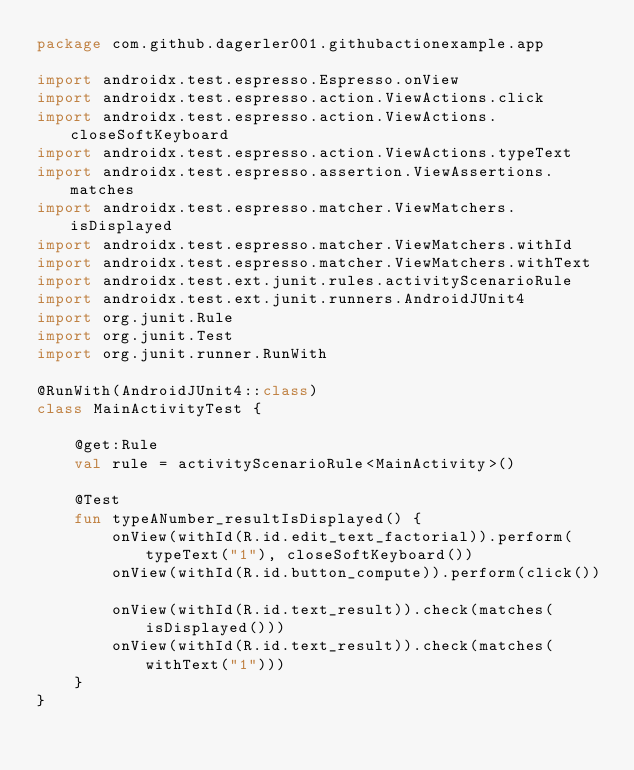Convert code to text. <code><loc_0><loc_0><loc_500><loc_500><_Kotlin_>package com.github.dagerler001.githubactionexample.app

import androidx.test.espresso.Espresso.onView
import androidx.test.espresso.action.ViewActions.click
import androidx.test.espresso.action.ViewActions.closeSoftKeyboard
import androidx.test.espresso.action.ViewActions.typeText
import androidx.test.espresso.assertion.ViewAssertions.matches
import androidx.test.espresso.matcher.ViewMatchers.isDisplayed
import androidx.test.espresso.matcher.ViewMatchers.withId
import androidx.test.espresso.matcher.ViewMatchers.withText
import androidx.test.ext.junit.rules.activityScenarioRule
import androidx.test.ext.junit.runners.AndroidJUnit4
import org.junit.Rule
import org.junit.Test
import org.junit.runner.RunWith

@RunWith(AndroidJUnit4::class)
class MainActivityTest {

    @get:Rule
    val rule = activityScenarioRule<MainActivity>()

    @Test
    fun typeANumber_resultIsDisplayed() {
        onView(withId(R.id.edit_text_factorial)).perform(typeText("1"), closeSoftKeyboard())
        onView(withId(R.id.button_compute)).perform(click())

        onView(withId(R.id.text_result)).check(matches(isDisplayed()))
        onView(withId(R.id.text_result)).check(matches(withText("1")))
    }
}
</code> 